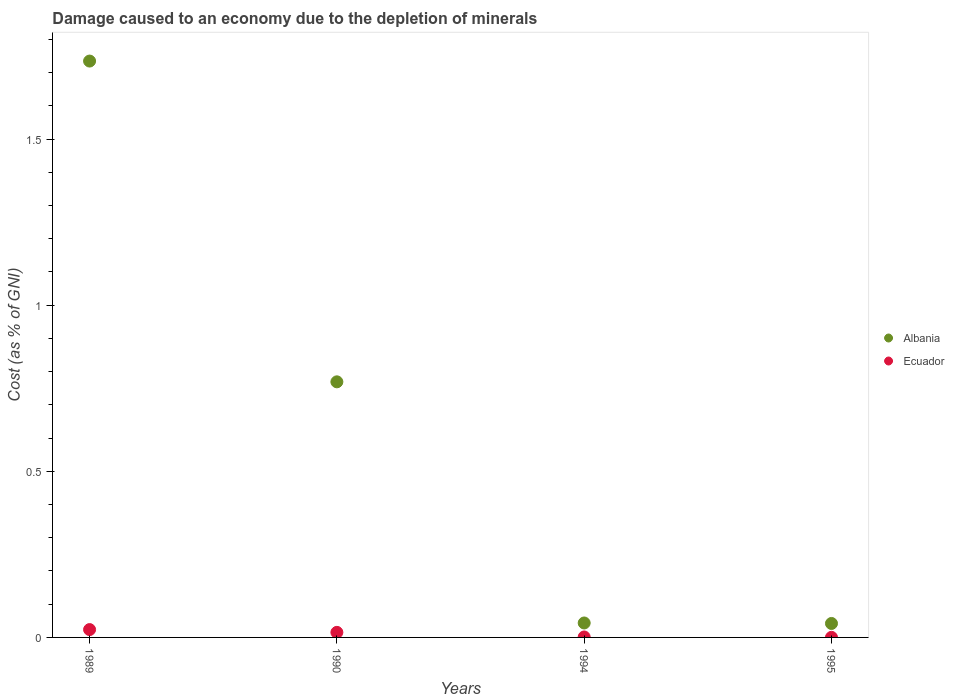How many different coloured dotlines are there?
Offer a terse response. 2. Is the number of dotlines equal to the number of legend labels?
Your answer should be very brief. Yes. What is the cost of damage caused due to the depletion of minerals in Albania in 1989?
Ensure brevity in your answer.  1.73. Across all years, what is the maximum cost of damage caused due to the depletion of minerals in Ecuador?
Keep it short and to the point. 0.02. Across all years, what is the minimum cost of damage caused due to the depletion of minerals in Ecuador?
Offer a terse response. 0. In which year was the cost of damage caused due to the depletion of minerals in Albania minimum?
Provide a short and direct response. 1995. What is the total cost of damage caused due to the depletion of minerals in Ecuador in the graph?
Your answer should be compact. 0.04. What is the difference between the cost of damage caused due to the depletion of minerals in Ecuador in 1989 and that in 1994?
Your answer should be compact. 0.02. What is the difference between the cost of damage caused due to the depletion of minerals in Ecuador in 1994 and the cost of damage caused due to the depletion of minerals in Albania in 1989?
Give a very brief answer. -1.73. What is the average cost of damage caused due to the depletion of minerals in Albania per year?
Give a very brief answer. 0.65. In the year 1989, what is the difference between the cost of damage caused due to the depletion of minerals in Albania and cost of damage caused due to the depletion of minerals in Ecuador?
Offer a terse response. 1.71. What is the ratio of the cost of damage caused due to the depletion of minerals in Albania in 1990 to that in 1994?
Your response must be concise. 17.69. Is the cost of damage caused due to the depletion of minerals in Albania in 1994 less than that in 1995?
Give a very brief answer. No. Is the difference between the cost of damage caused due to the depletion of minerals in Albania in 1989 and 1990 greater than the difference between the cost of damage caused due to the depletion of minerals in Ecuador in 1989 and 1990?
Give a very brief answer. Yes. What is the difference between the highest and the second highest cost of damage caused due to the depletion of minerals in Ecuador?
Your answer should be very brief. 0.01. What is the difference between the highest and the lowest cost of damage caused due to the depletion of minerals in Albania?
Offer a very short reply. 1.69. In how many years, is the cost of damage caused due to the depletion of minerals in Ecuador greater than the average cost of damage caused due to the depletion of minerals in Ecuador taken over all years?
Make the answer very short. 2. Is the sum of the cost of damage caused due to the depletion of minerals in Albania in 1990 and 1995 greater than the maximum cost of damage caused due to the depletion of minerals in Ecuador across all years?
Ensure brevity in your answer.  Yes. Is the cost of damage caused due to the depletion of minerals in Ecuador strictly greater than the cost of damage caused due to the depletion of minerals in Albania over the years?
Give a very brief answer. No. How many dotlines are there?
Your answer should be compact. 2. Does the graph contain any zero values?
Give a very brief answer. No. Does the graph contain grids?
Your response must be concise. No. Where does the legend appear in the graph?
Your response must be concise. Center right. What is the title of the graph?
Ensure brevity in your answer.  Damage caused to an economy due to the depletion of minerals. Does "Guyana" appear as one of the legend labels in the graph?
Ensure brevity in your answer.  No. What is the label or title of the X-axis?
Give a very brief answer. Years. What is the label or title of the Y-axis?
Offer a terse response. Cost (as % of GNI). What is the Cost (as % of GNI) in Albania in 1989?
Give a very brief answer. 1.73. What is the Cost (as % of GNI) in Ecuador in 1989?
Give a very brief answer. 0.02. What is the Cost (as % of GNI) in Albania in 1990?
Keep it short and to the point. 0.77. What is the Cost (as % of GNI) in Ecuador in 1990?
Ensure brevity in your answer.  0.02. What is the Cost (as % of GNI) of Albania in 1994?
Offer a very short reply. 0.04. What is the Cost (as % of GNI) of Ecuador in 1994?
Keep it short and to the point. 0. What is the Cost (as % of GNI) of Albania in 1995?
Keep it short and to the point. 0.04. What is the Cost (as % of GNI) in Ecuador in 1995?
Your response must be concise. 0. Across all years, what is the maximum Cost (as % of GNI) of Albania?
Provide a short and direct response. 1.73. Across all years, what is the maximum Cost (as % of GNI) of Ecuador?
Your answer should be compact. 0.02. Across all years, what is the minimum Cost (as % of GNI) in Albania?
Your response must be concise. 0.04. Across all years, what is the minimum Cost (as % of GNI) in Ecuador?
Your answer should be compact. 0. What is the total Cost (as % of GNI) of Albania in the graph?
Your answer should be very brief. 2.59. What is the total Cost (as % of GNI) of Ecuador in the graph?
Offer a terse response. 0.04. What is the difference between the Cost (as % of GNI) of Albania in 1989 and that in 1990?
Offer a terse response. 0.97. What is the difference between the Cost (as % of GNI) in Ecuador in 1989 and that in 1990?
Ensure brevity in your answer.  0.01. What is the difference between the Cost (as % of GNI) of Albania in 1989 and that in 1994?
Offer a very short reply. 1.69. What is the difference between the Cost (as % of GNI) in Ecuador in 1989 and that in 1994?
Your answer should be compact. 0.02. What is the difference between the Cost (as % of GNI) of Albania in 1989 and that in 1995?
Offer a terse response. 1.69. What is the difference between the Cost (as % of GNI) of Ecuador in 1989 and that in 1995?
Give a very brief answer. 0.02. What is the difference between the Cost (as % of GNI) of Albania in 1990 and that in 1994?
Offer a very short reply. 0.73. What is the difference between the Cost (as % of GNI) in Ecuador in 1990 and that in 1994?
Your response must be concise. 0.01. What is the difference between the Cost (as % of GNI) in Albania in 1990 and that in 1995?
Your response must be concise. 0.73. What is the difference between the Cost (as % of GNI) of Ecuador in 1990 and that in 1995?
Your answer should be very brief. 0.01. What is the difference between the Cost (as % of GNI) of Albania in 1994 and that in 1995?
Provide a short and direct response. 0. What is the difference between the Cost (as % of GNI) of Ecuador in 1994 and that in 1995?
Make the answer very short. 0. What is the difference between the Cost (as % of GNI) of Albania in 1989 and the Cost (as % of GNI) of Ecuador in 1990?
Offer a terse response. 1.72. What is the difference between the Cost (as % of GNI) of Albania in 1989 and the Cost (as % of GNI) of Ecuador in 1994?
Provide a short and direct response. 1.73. What is the difference between the Cost (as % of GNI) in Albania in 1989 and the Cost (as % of GNI) in Ecuador in 1995?
Keep it short and to the point. 1.73. What is the difference between the Cost (as % of GNI) of Albania in 1990 and the Cost (as % of GNI) of Ecuador in 1994?
Provide a short and direct response. 0.77. What is the difference between the Cost (as % of GNI) of Albania in 1990 and the Cost (as % of GNI) of Ecuador in 1995?
Offer a very short reply. 0.77. What is the difference between the Cost (as % of GNI) of Albania in 1994 and the Cost (as % of GNI) of Ecuador in 1995?
Offer a terse response. 0.04. What is the average Cost (as % of GNI) of Albania per year?
Keep it short and to the point. 0.65. What is the average Cost (as % of GNI) of Ecuador per year?
Keep it short and to the point. 0.01. In the year 1989, what is the difference between the Cost (as % of GNI) in Albania and Cost (as % of GNI) in Ecuador?
Ensure brevity in your answer.  1.71. In the year 1990, what is the difference between the Cost (as % of GNI) in Albania and Cost (as % of GNI) in Ecuador?
Your response must be concise. 0.75. In the year 1994, what is the difference between the Cost (as % of GNI) in Albania and Cost (as % of GNI) in Ecuador?
Ensure brevity in your answer.  0.04. In the year 1995, what is the difference between the Cost (as % of GNI) of Albania and Cost (as % of GNI) of Ecuador?
Your answer should be compact. 0.04. What is the ratio of the Cost (as % of GNI) of Albania in 1989 to that in 1990?
Give a very brief answer. 2.25. What is the ratio of the Cost (as % of GNI) in Ecuador in 1989 to that in 1990?
Offer a very short reply. 1.55. What is the ratio of the Cost (as % of GNI) of Albania in 1989 to that in 1994?
Keep it short and to the point. 39.9. What is the ratio of the Cost (as % of GNI) of Ecuador in 1989 to that in 1994?
Keep it short and to the point. 17.06. What is the ratio of the Cost (as % of GNI) in Albania in 1989 to that in 1995?
Your response must be concise. 41.29. What is the ratio of the Cost (as % of GNI) of Ecuador in 1989 to that in 1995?
Make the answer very short. 88.36. What is the ratio of the Cost (as % of GNI) of Albania in 1990 to that in 1994?
Your response must be concise. 17.69. What is the ratio of the Cost (as % of GNI) of Ecuador in 1990 to that in 1994?
Keep it short and to the point. 11.01. What is the ratio of the Cost (as % of GNI) of Albania in 1990 to that in 1995?
Provide a succinct answer. 18.31. What is the ratio of the Cost (as % of GNI) in Ecuador in 1990 to that in 1995?
Give a very brief answer. 57.05. What is the ratio of the Cost (as % of GNI) in Albania in 1994 to that in 1995?
Offer a very short reply. 1.03. What is the ratio of the Cost (as % of GNI) of Ecuador in 1994 to that in 1995?
Your response must be concise. 5.18. What is the difference between the highest and the second highest Cost (as % of GNI) of Albania?
Give a very brief answer. 0.97. What is the difference between the highest and the second highest Cost (as % of GNI) in Ecuador?
Your response must be concise. 0.01. What is the difference between the highest and the lowest Cost (as % of GNI) in Albania?
Provide a succinct answer. 1.69. What is the difference between the highest and the lowest Cost (as % of GNI) of Ecuador?
Provide a succinct answer. 0.02. 